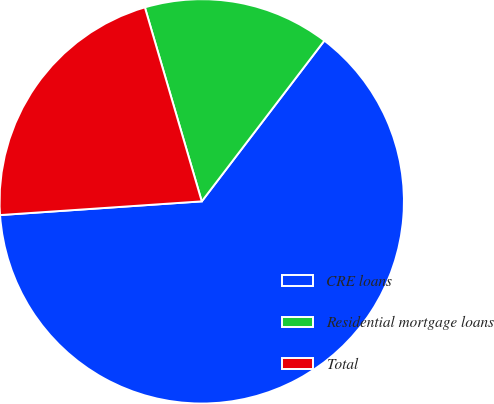Convert chart to OTSL. <chart><loc_0><loc_0><loc_500><loc_500><pie_chart><fcel>CRE loans<fcel>Residential mortgage loans<fcel>Total<nl><fcel>63.55%<fcel>14.91%<fcel>21.54%<nl></chart> 